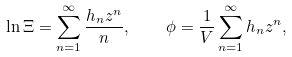<formula> <loc_0><loc_0><loc_500><loc_500>\ln \Xi = \sum _ { n = 1 } ^ { \infty } \frac { h _ { n } z ^ { n } } { n } , \quad \phi = \frac { 1 } { V } \sum _ { n = 1 } ^ { \infty } h _ { n } z ^ { n } ,</formula> 